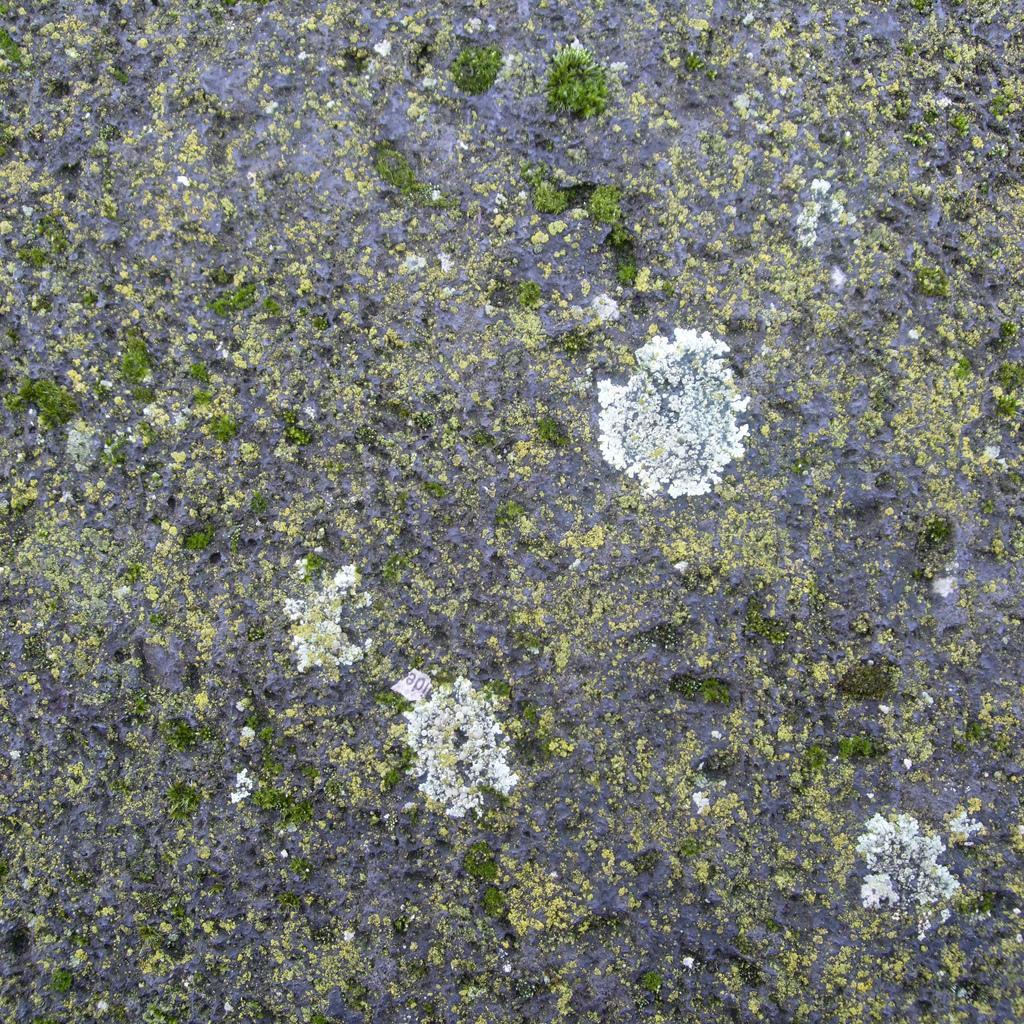Can you describe this image briefly? In this image it's look like an algae in green and white color. 